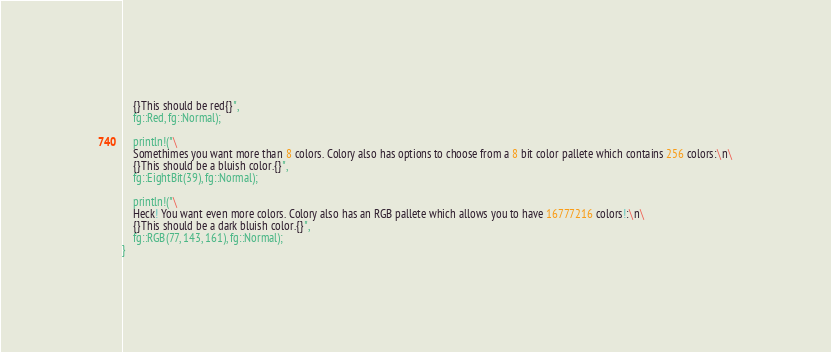Convert code to text. <code><loc_0><loc_0><loc_500><loc_500><_Rust_>	{}This should be red{}",
	fg::Red, fg::Normal);

	println!("\
	Somethimes you want more than 8 colors. Colory also has options to choose from a 8 bit color pallete which contains 256 colors:\n\
	{}This should be a bluish color.{}",
	fg::EightBit(39), fg::Normal);

	println!("\
	Heck! You want even more colors. Colory also has an RGB pallete which allows you to have 16777216 colors!:\n\
	{}This should be a dark bluish color.{}",
	fg::RGB(77, 143, 161), fg::Normal);
}</code> 